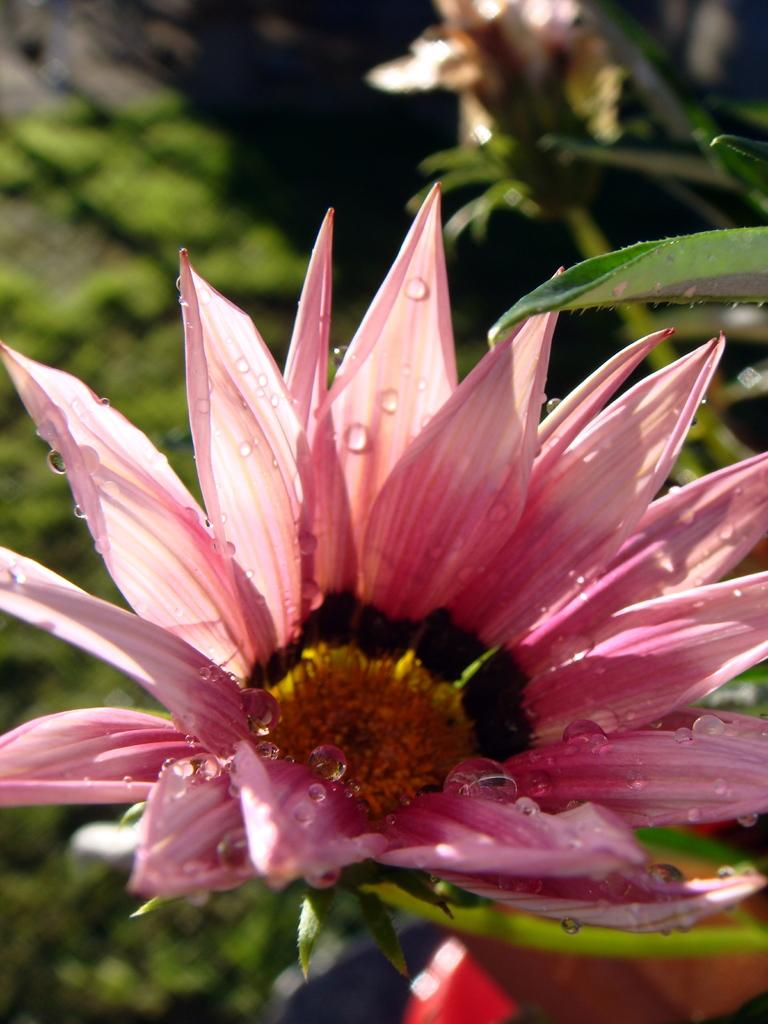What type of flower is in the image? There is a pink flower in the image. What color are the leaves in the image? There are green leaves in the image. Can you describe the background of the image? The background of the image is blurred. What type of competition is taking place during the recess in the image? There is no recess or competition present in the image; it features a pink flower and green leaves with a blurred background. 